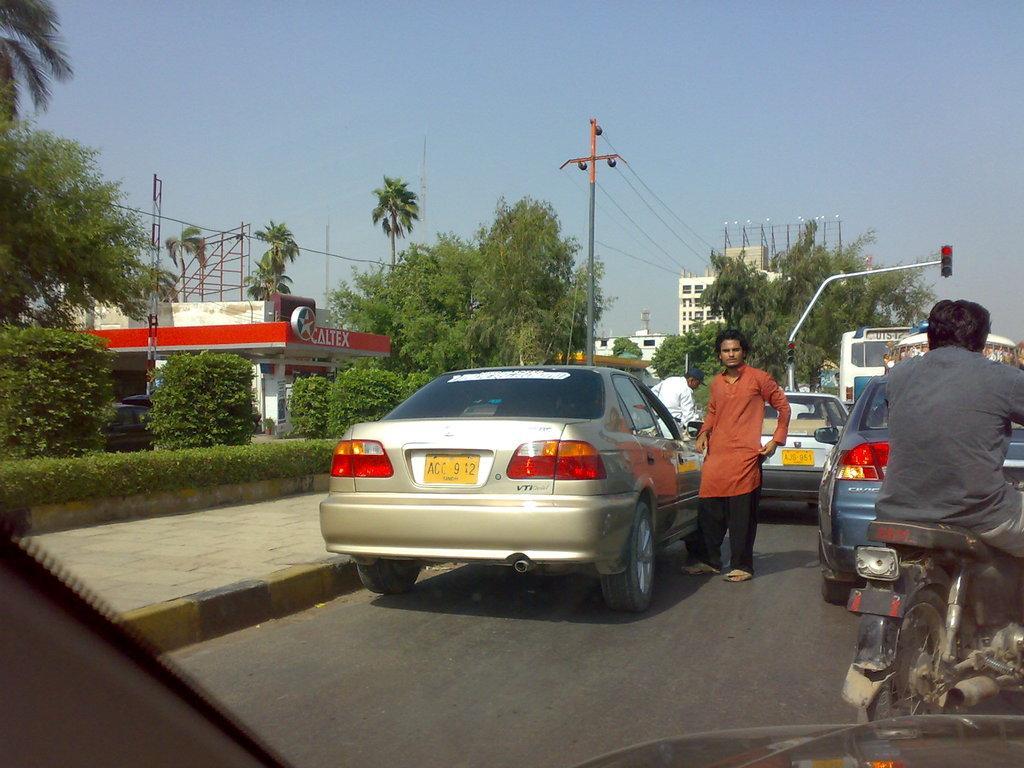Please provide a concise description of this image. In the background we can see the sky, hoarding stands, trees, building, transmission pole and wires. On the left side of the picture we can see the store, plants, it seems like a black car and the footpath. In this picture we can see the people and the vehicles. On the right side of the picture we can see a man riding a bike. We can see the traffic signals. 